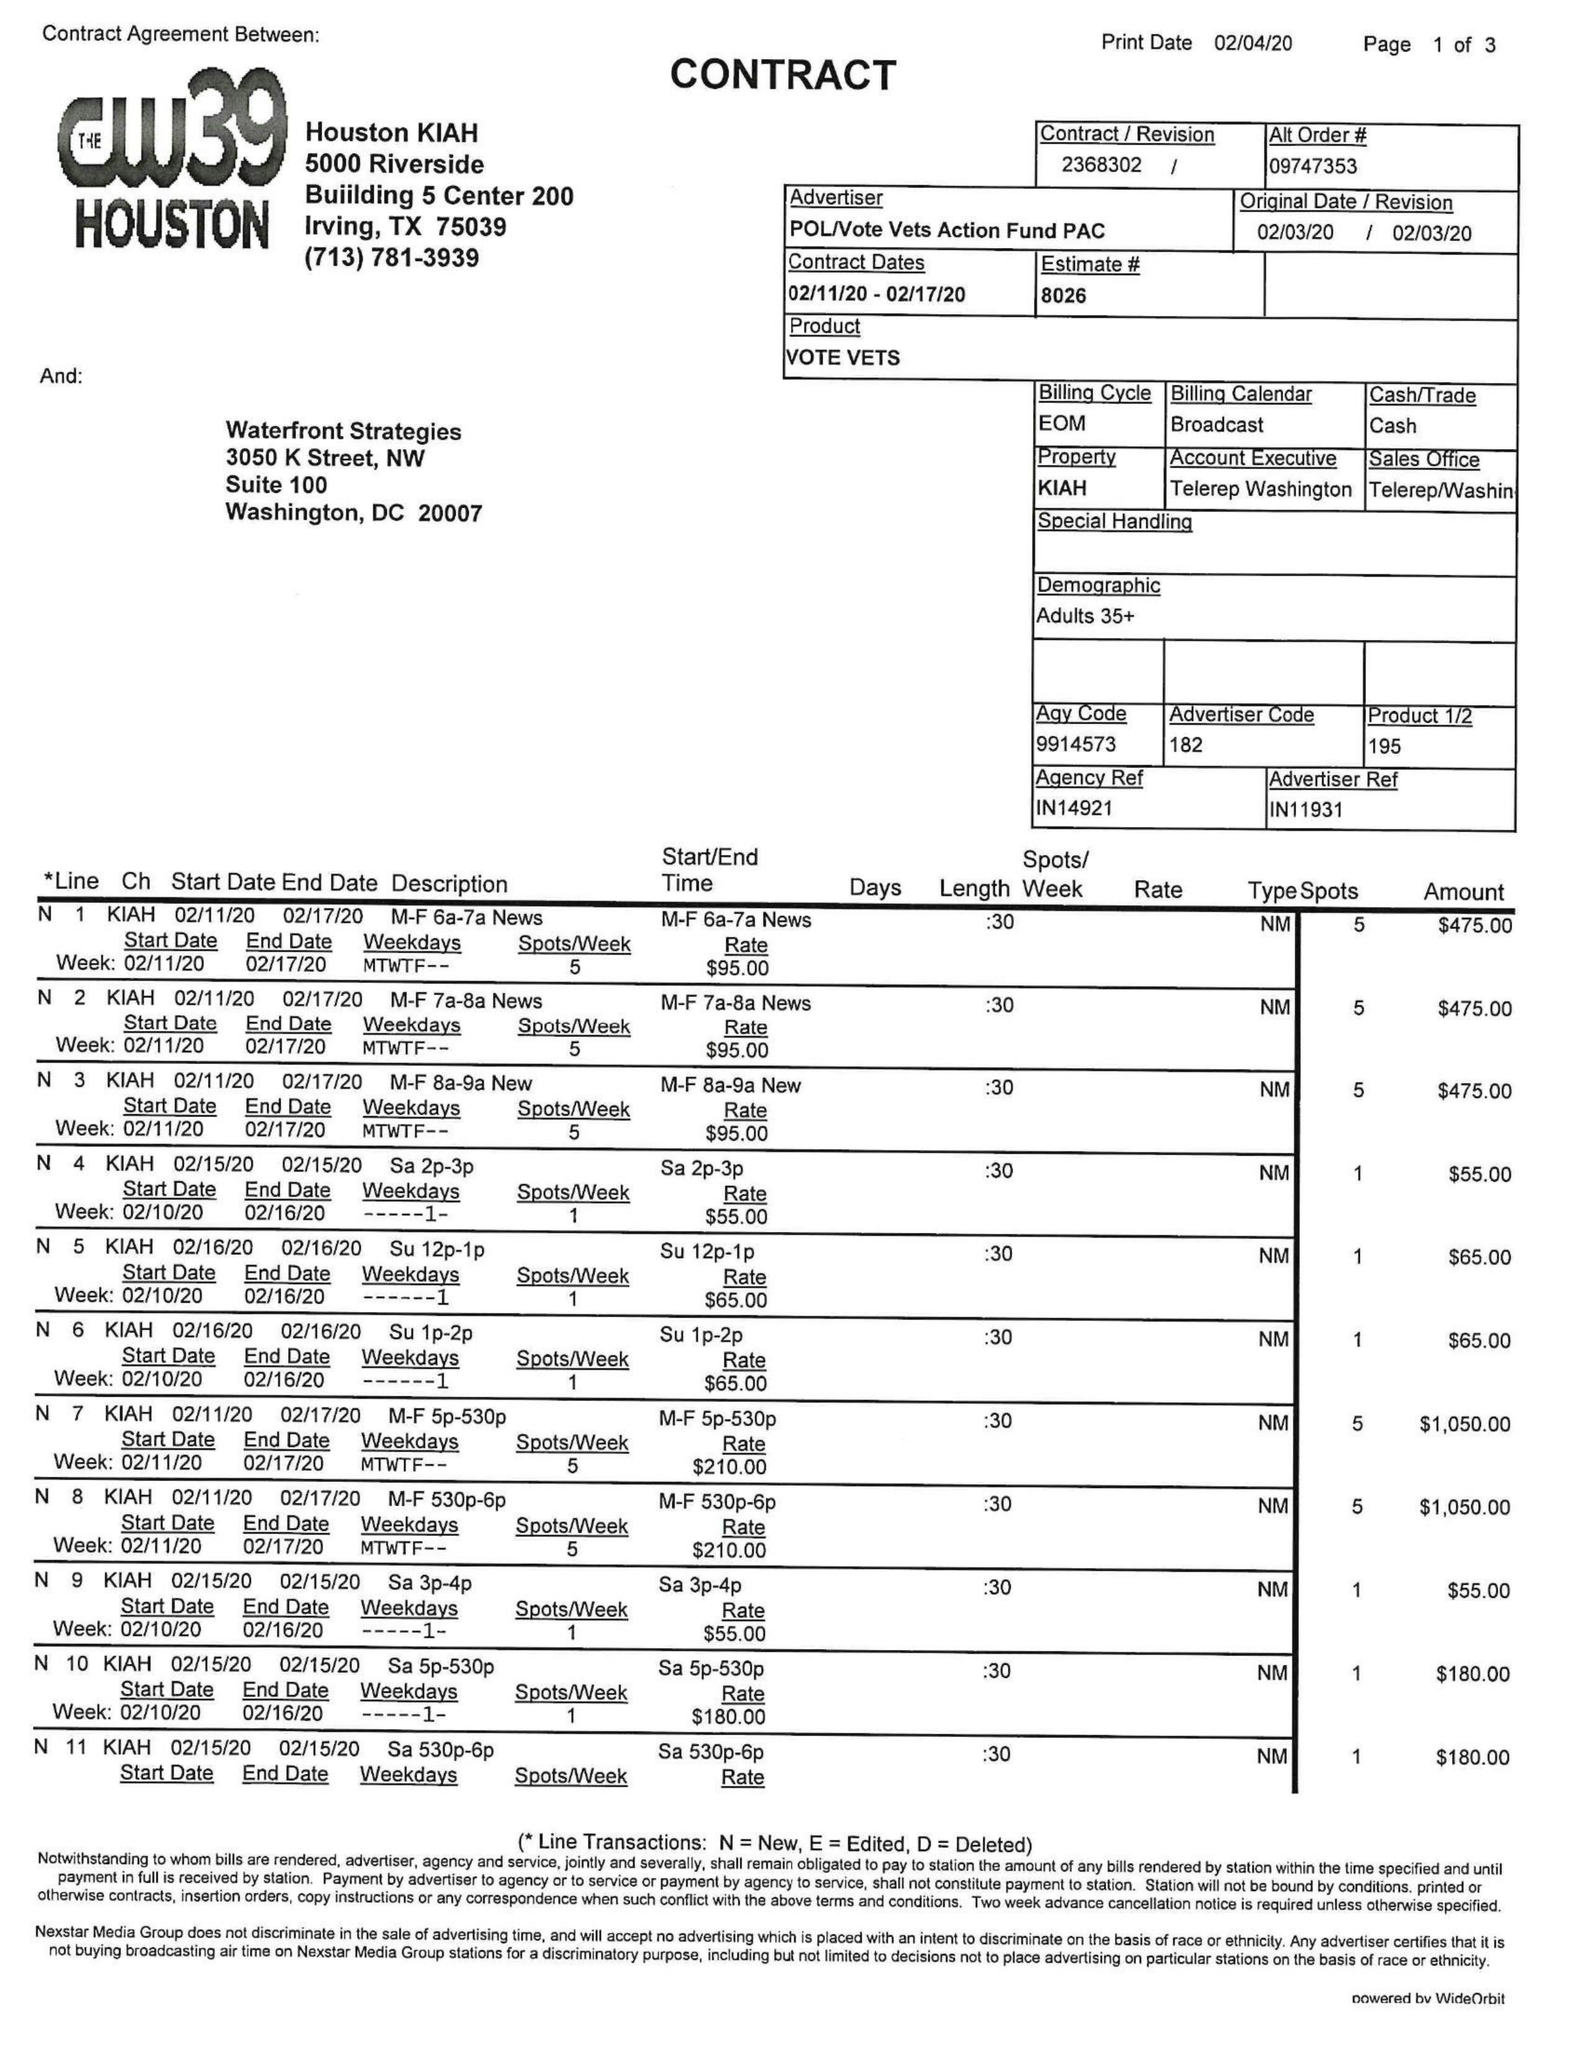What is the value for the flight_from?
Answer the question using a single word or phrase. 02/11/20 